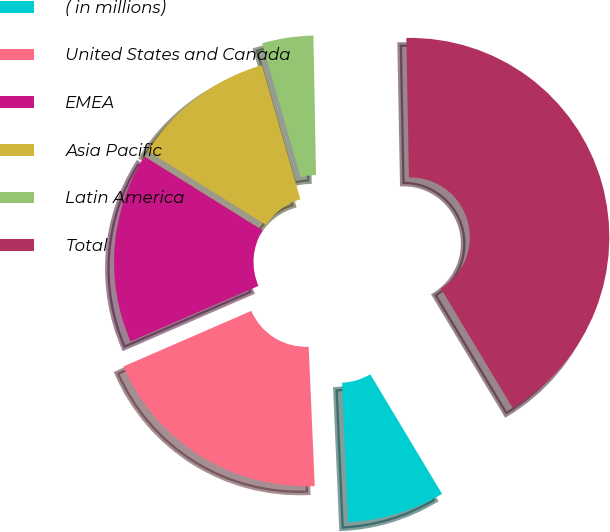<chart> <loc_0><loc_0><loc_500><loc_500><pie_chart><fcel>( in millions)<fcel>United States and Canada<fcel>EMEA<fcel>Asia Pacific<fcel>Latin America<fcel>Total<nl><fcel>7.91%<fcel>19.17%<fcel>15.42%<fcel>11.66%<fcel>4.15%<fcel>41.7%<nl></chart> 